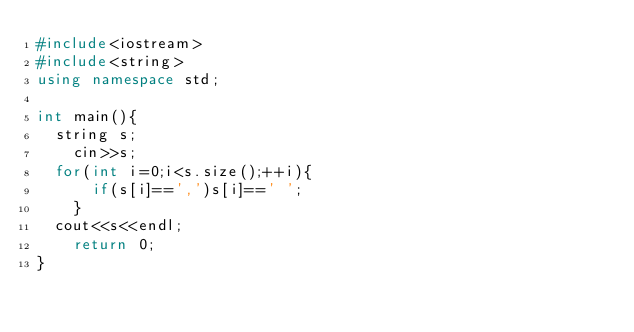Convert code to text. <code><loc_0><loc_0><loc_500><loc_500><_C++_>#include<iostream>
#include<string>
using namespace std;

int main(){
	string s;
  	cin>>s;
 	for(int i=0;i<s.size();++i){
    	if(s[i]==',')s[i]==' ';
    }
	cout<<s<<endl;
  	return 0;
}</code> 